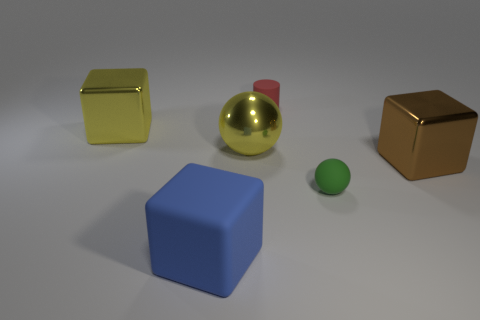Could you explain the lighting source in this image because it looks like there’s a shadow beneath the objects? Certainly! The shadows under the objects suggest that the primary light source in this image is above and slightly to the left from the perspective of the viewer. This overhead lighting casts soft-edged shadows that help define the spatial relationships among the objects on the surface. If this image was designed, what could be the purpose of having these objects in these specific materials? If this scene was intentionally crafted, it could be illustrating a comparison of textures and reflections. The varied materials, such as matte plastic and reflective metal, allow the viewer to see how different surfaces interact with light. This could be useful for educational purposes, like teaching about materials in a design course, or for aesthetic study in a visual arts context. 